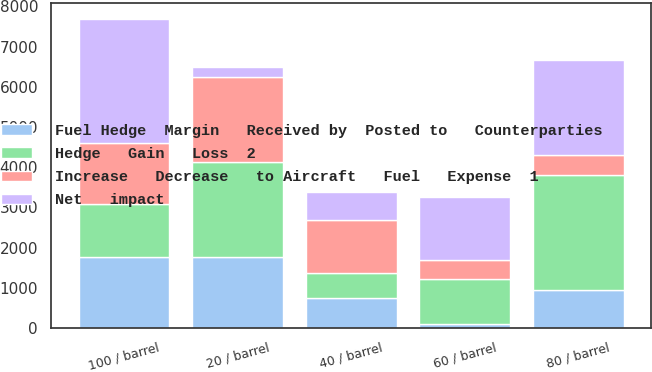<chart> <loc_0><loc_0><loc_500><loc_500><stacked_bar_chart><ecel><fcel>20 / barrel<fcel>40 / barrel<fcel>60 / barrel<fcel>80 / barrel<fcel>100 / barrel<nl><fcel>Hedge   Gain   Loss  2<fcel>2371<fcel>628<fcel>1115<fcel>2858<fcel>1312<nl><fcel>Increase   Decrease   to Aircraft   Fuel   Expense  1<fcel>2101<fcel>1312<fcel>462<fcel>505<fcel>1519<nl><fcel>Net   impact<fcel>270<fcel>684<fcel>1577<fcel>2353<fcel>3083<nl><fcel>Fuel Hedge  Margin   Received by  Posted to   Counterparties<fcel>1758<fcel>753<fcel>108<fcel>943<fcel>1776<nl></chart> 